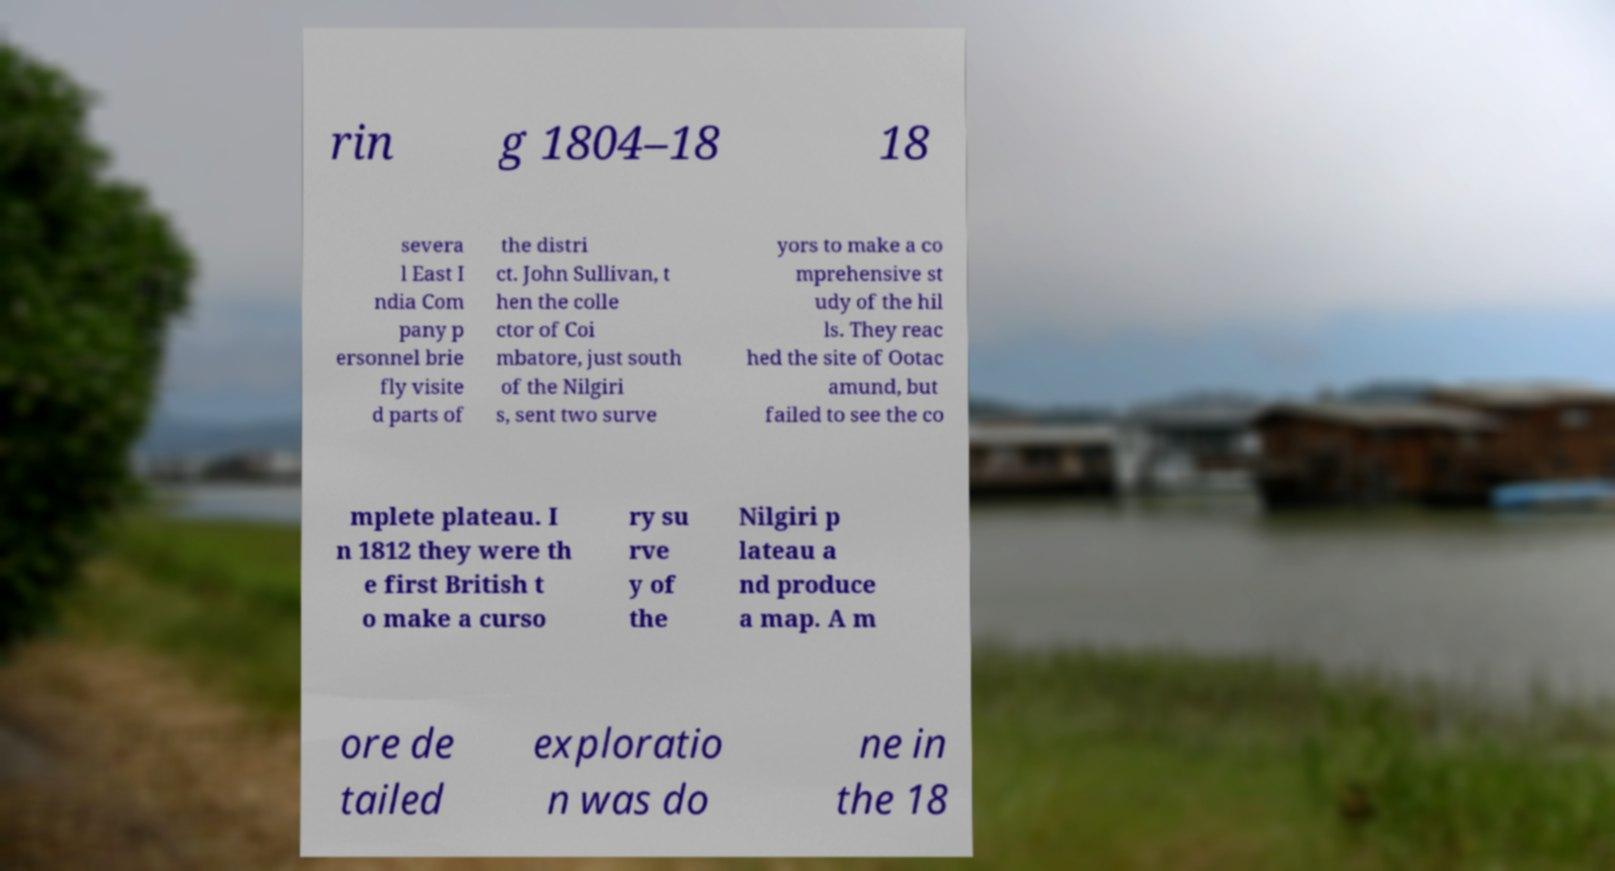What messages or text are displayed in this image? I need them in a readable, typed format. rin g 1804–18 18 severa l East I ndia Com pany p ersonnel brie fly visite d parts of the distri ct. John Sullivan, t hen the colle ctor of Coi mbatore, just south of the Nilgiri s, sent two surve yors to make a co mprehensive st udy of the hil ls. They reac hed the site of Ootac amund, but failed to see the co mplete plateau. I n 1812 they were th e first British t o make a curso ry su rve y of the Nilgiri p lateau a nd produce a map. A m ore de tailed exploratio n was do ne in the 18 